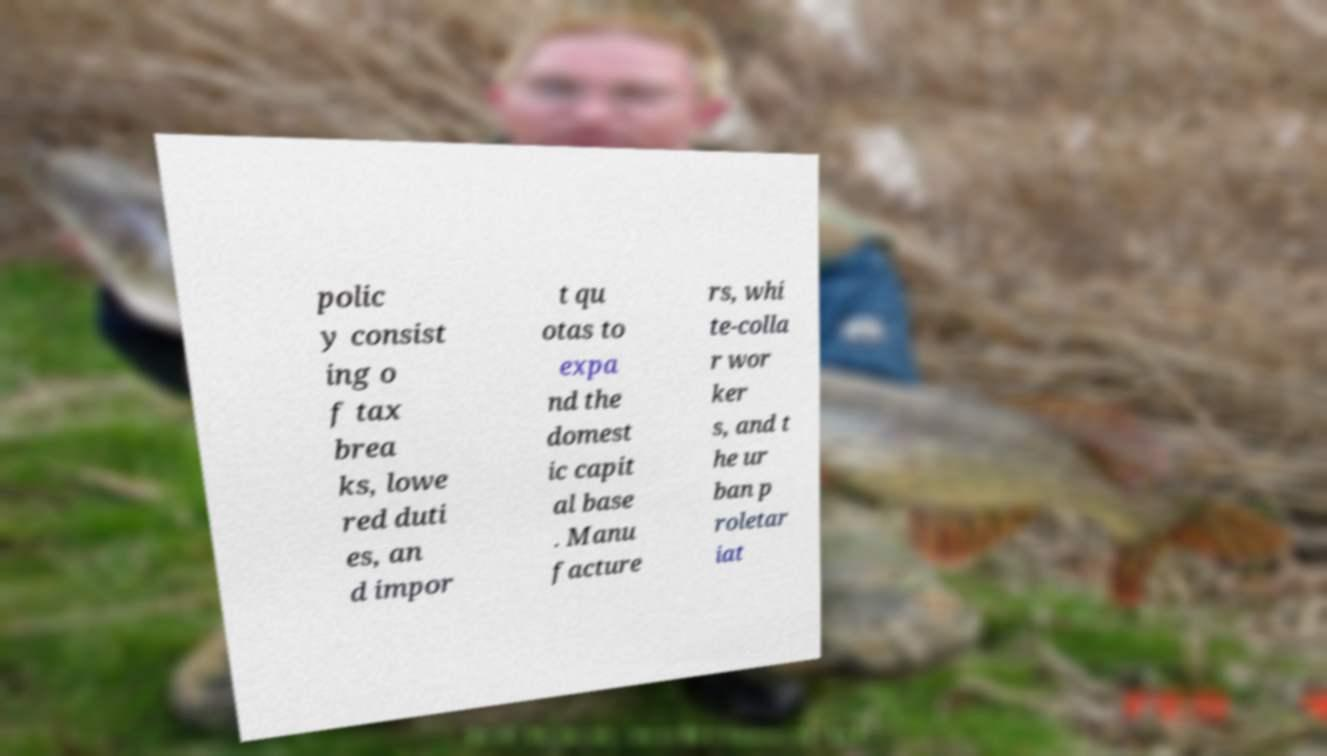There's text embedded in this image that I need extracted. Can you transcribe it verbatim? polic y consist ing o f tax brea ks, lowe red duti es, an d impor t qu otas to expa nd the domest ic capit al base . Manu facture rs, whi te-colla r wor ker s, and t he ur ban p roletar iat 